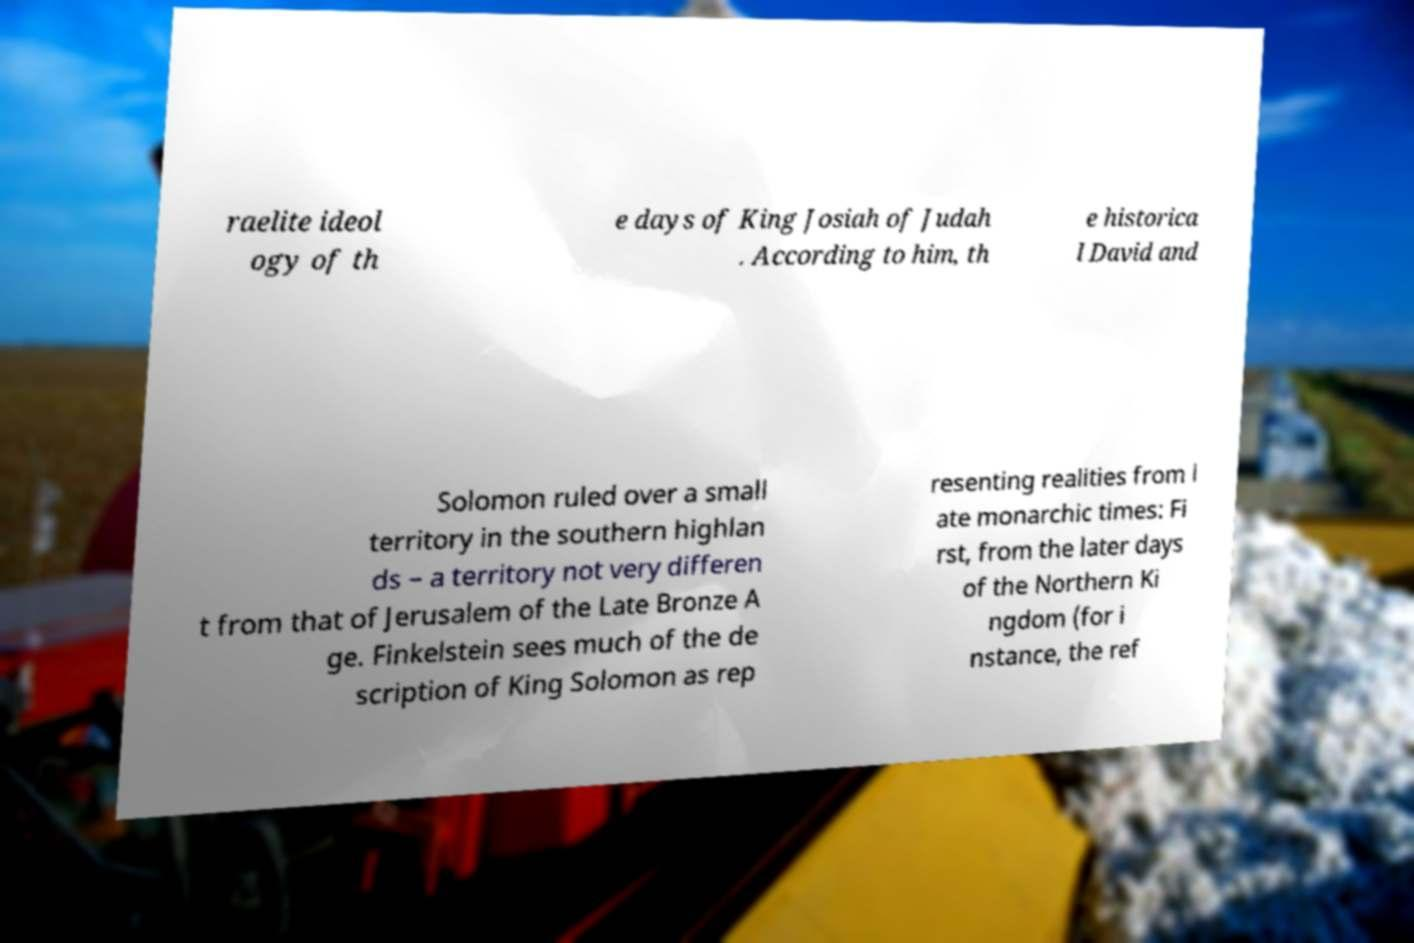Could you assist in decoding the text presented in this image and type it out clearly? raelite ideol ogy of th e days of King Josiah of Judah . According to him, th e historica l David and Solomon ruled over a small territory in the southern highlan ds – a territory not very differen t from that of Jerusalem of the Late Bronze A ge. Finkelstein sees much of the de scription of King Solomon as rep resenting realities from l ate monarchic times: Fi rst, from the later days of the Northern Ki ngdom (for i nstance, the ref 